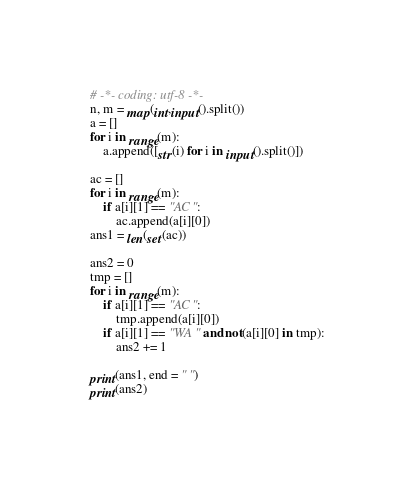<code> <loc_0><loc_0><loc_500><loc_500><_Python_># -*- coding: utf-8 -*-
n, m = map(int,input().split())
a = []
for i in range(m):
    a.append([str(i) for i in input().split()])

ac = []
for i in range(m):
    if a[i][1] == "AC":
        ac.append(a[i][0])
ans1 = len(set(ac))

ans2 = 0
tmp = []
for i in range(m):
    if a[i][1] == "AC":
        tmp.append(a[i][0])
    if a[i][1] == "WA" and not(a[i][0] in tmp):
        ans2 += 1

print(ans1, end = " ")
print(ans2)
</code> 